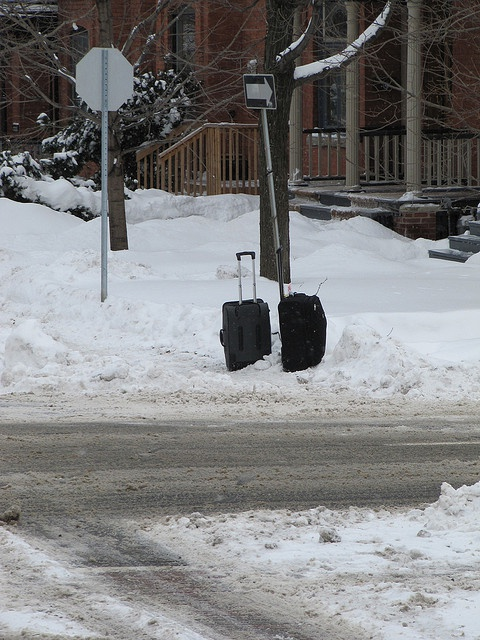Describe the objects in this image and their specific colors. I can see suitcase in gray, black, darkgray, and lightgray tones, suitcase in gray, black, and lightgray tones, and stop sign in gray tones in this image. 